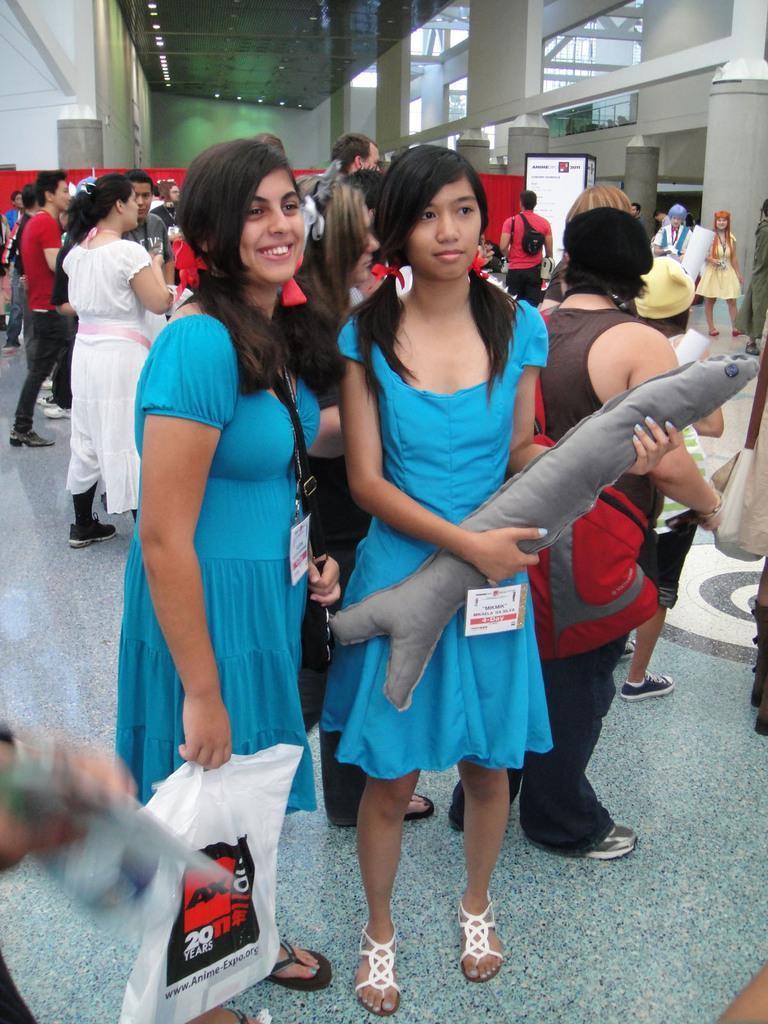Please provide a concise description of this image. There are two ladies standing. Lady on the left side is wearing a tag and bag. She is holding a cover. Other lady is holding a toy fish. In the back there are many people. Also there are pillars. And there is a board. Some people are wearing caps. 